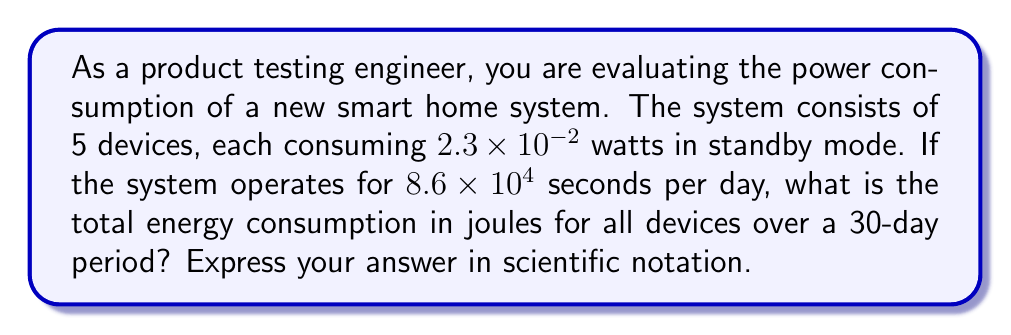Can you answer this question? Let's break this down step-by-step:

1) First, calculate the total power consumption of all devices:
   $P_{total} = 5 \times (2.3 \times 10^{-2})$ watts
   $P_{total} = 1.15 \times 10^{-1}$ watts

2) Now, calculate the total time in seconds for 30 days:
   $T = 30 \times (8.6 \times 10^4)$ seconds
   $T = 2.58 \times 10^6$ seconds

3) Energy is calculated using the formula $E = P \times T$, where:
   $E$ is energy in joules
   $P$ is power in watts
   $T$ is time in seconds

4) Substitute the values:
   $E = (1.15 \times 10^{-1}) \times (2.58 \times 10^6)$

5) Multiply the numbers and combine the exponents:
   $E = (1.15 \times 2.58) \times 10^{-1+6}$
   $E = 2.967 \times 10^5$ joules

6) Round to 3 significant figures:
   $E = 2.97 \times 10^5$ joules
Answer: $2.97 \times 10^5$ J 